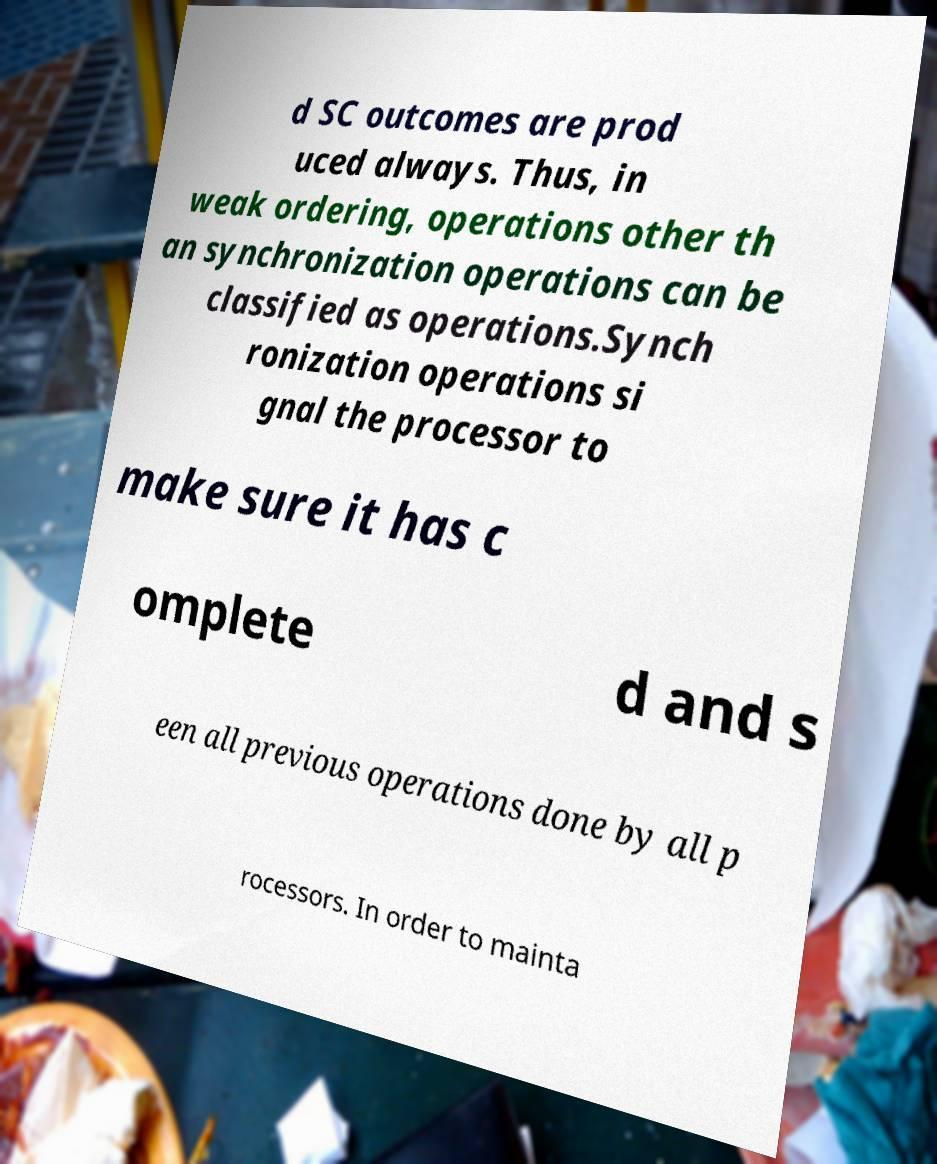Could you assist in decoding the text presented in this image and type it out clearly? d SC outcomes are prod uced always. Thus, in weak ordering, operations other th an synchronization operations can be classified as operations.Synch ronization operations si gnal the processor to make sure it has c omplete d and s een all previous operations done by all p rocessors. In order to mainta 